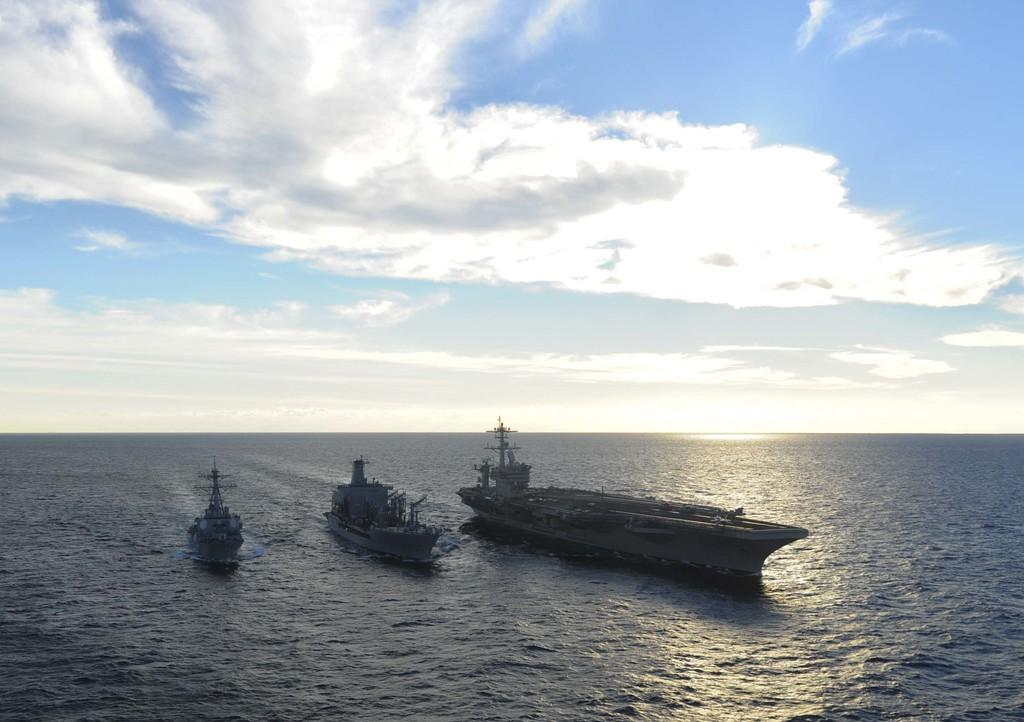What is the main subject of the image? The main subject of the image is ships. Where are the ships located? The ships are on the water. What can be seen in the sky in the image? There are clouds visible in the sky. How many church bells can be heard ringing in the image? There are no church bells or any indication of a church in the image; it features ships on the water with clouds in the sky. 